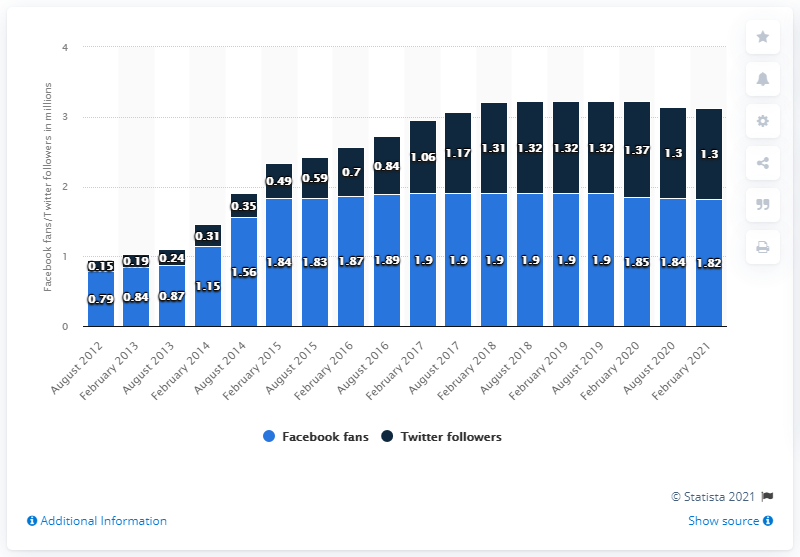Give some essential details in this illustration. The Detroit Lions football team had 1.82 million Facebook followers in February 2021. 